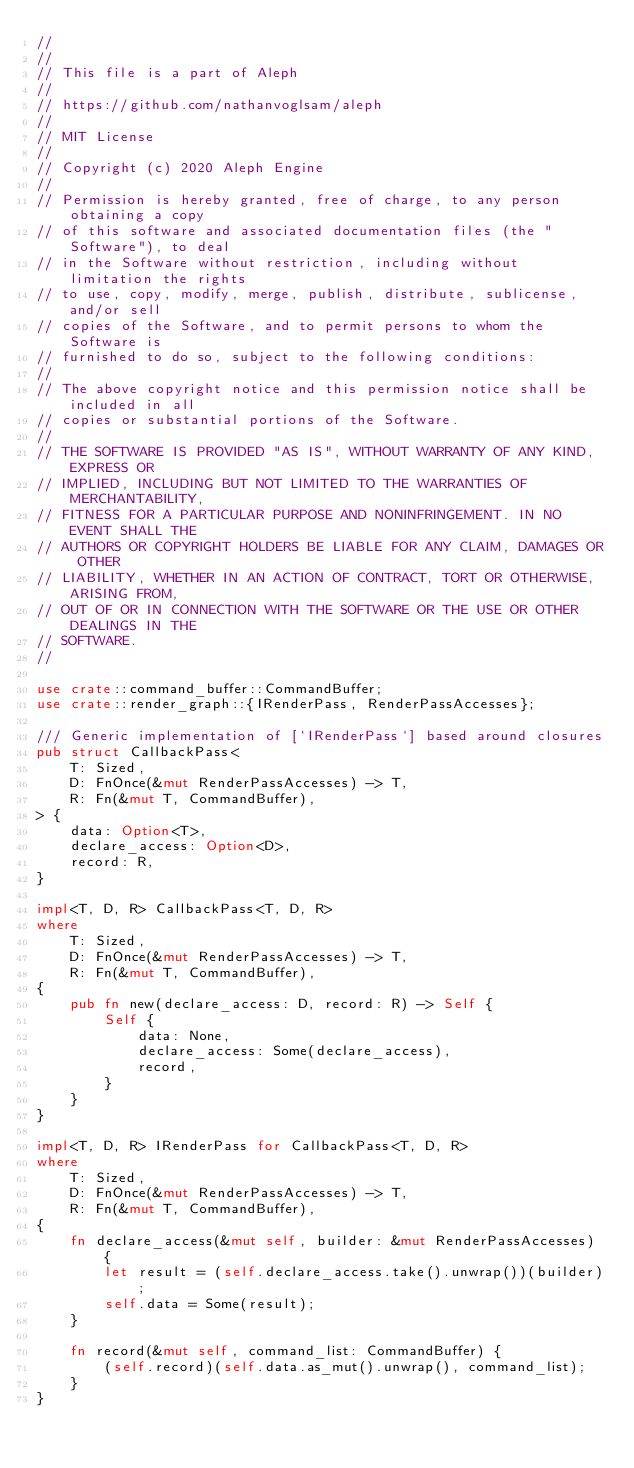<code> <loc_0><loc_0><loc_500><loc_500><_Rust_>//
//
// This file is a part of Aleph
//
// https://github.com/nathanvoglsam/aleph
//
// MIT License
//
// Copyright (c) 2020 Aleph Engine
//
// Permission is hereby granted, free of charge, to any person obtaining a copy
// of this software and associated documentation files (the "Software"), to deal
// in the Software without restriction, including without limitation the rights
// to use, copy, modify, merge, publish, distribute, sublicense, and/or sell
// copies of the Software, and to permit persons to whom the Software is
// furnished to do so, subject to the following conditions:
//
// The above copyright notice and this permission notice shall be included in all
// copies or substantial portions of the Software.
//
// THE SOFTWARE IS PROVIDED "AS IS", WITHOUT WARRANTY OF ANY KIND, EXPRESS OR
// IMPLIED, INCLUDING BUT NOT LIMITED TO THE WARRANTIES OF MERCHANTABILITY,
// FITNESS FOR A PARTICULAR PURPOSE AND NONINFRINGEMENT. IN NO EVENT SHALL THE
// AUTHORS OR COPYRIGHT HOLDERS BE LIABLE FOR ANY CLAIM, DAMAGES OR OTHER
// LIABILITY, WHETHER IN AN ACTION OF CONTRACT, TORT OR OTHERWISE, ARISING FROM,
// OUT OF OR IN CONNECTION WITH THE SOFTWARE OR THE USE OR OTHER DEALINGS IN THE
// SOFTWARE.
//

use crate::command_buffer::CommandBuffer;
use crate::render_graph::{IRenderPass, RenderPassAccesses};

/// Generic implementation of [`IRenderPass`] based around closures
pub struct CallbackPass<
    T: Sized,
    D: FnOnce(&mut RenderPassAccesses) -> T,
    R: Fn(&mut T, CommandBuffer),
> {
    data: Option<T>,
    declare_access: Option<D>,
    record: R,
}

impl<T, D, R> CallbackPass<T, D, R>
where
    T: Sized,
    D: FnOnce(&mut RenderPassAccesses) -> T,
    R: Fn(&mut T, CommandBuffer),
{
    pub fn new(declare_access: D, record: R) -> Self {
        Self {
            data: None,
            declare_access: Some(declare_access),
            record,
        }
    }
}

impl<T, D, R> IRenderPass for CallbackPass<T, D, R>
where
    T: Sized,
    D: FnOnce(&mut RenderPassAccesses) -> T,
    R: Fn(&mut T, CommandBuffer),
{
    fn declare_access(&mut self, builder: &mut RenderPassAccesses) {
        let result = (self.declare_access.take().unwrap())(builder);
        self.data = Some(result);
    }

    fn record(&mut self, command_list: CommandBuffer) {
        (self.record)(self.data.as_mut().unwrap(), command_list);
    }
}
</code> 